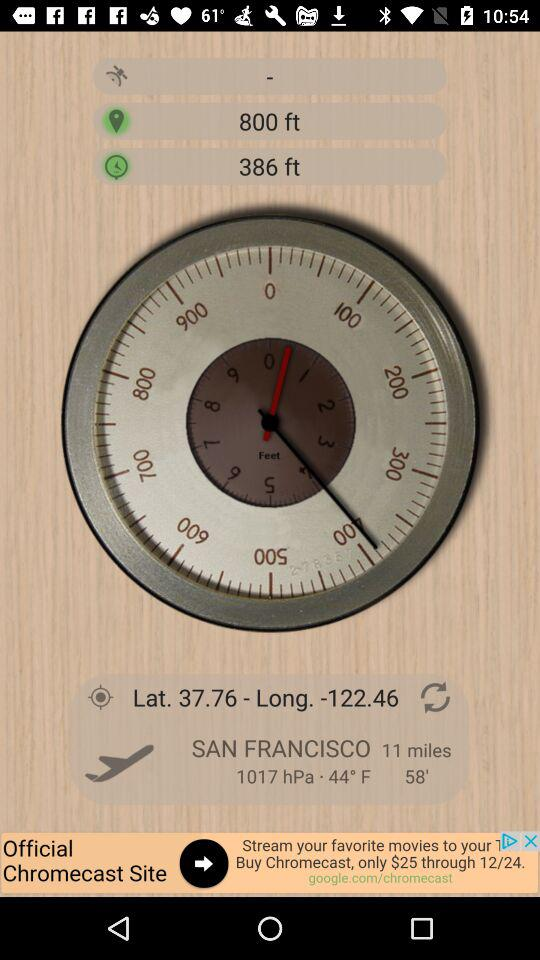What are the latitude and longitude numbers? The latitude and longitude numbers are 37.76 and 122.46. 